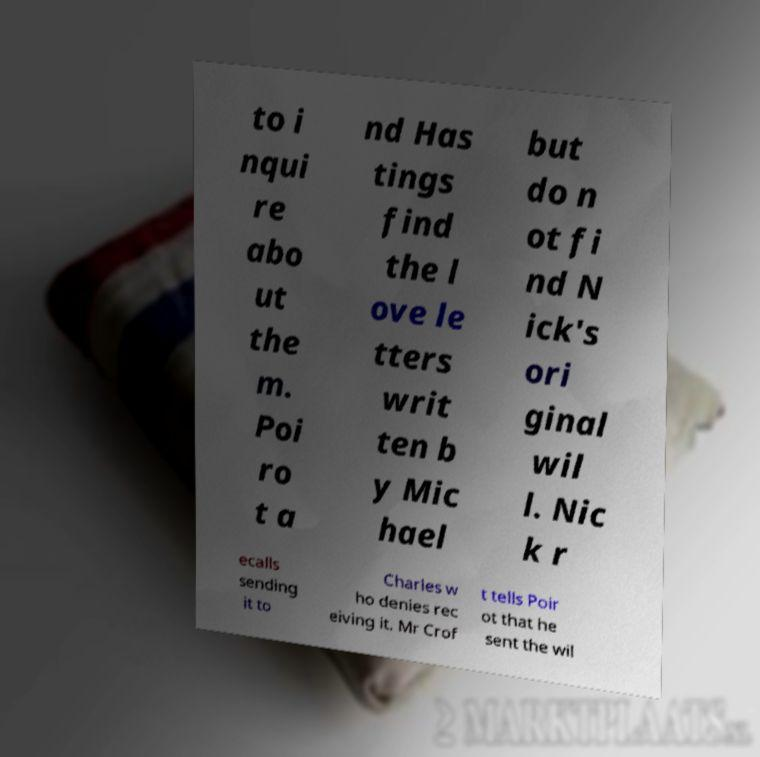For documentation purposes, I need the text within this image transcribed. Could you provide that? to i nqui re abo ut the m. Poi ro t a nd Has tings find the l ove le tters writ ten b y Mic hael but do n ot fi nd N ick's ori ginal wil l. Nic k r ecalls sending it to Charles w ho denies rec eiving it. Mr Crof t tells Poir ot that he sent the wil 